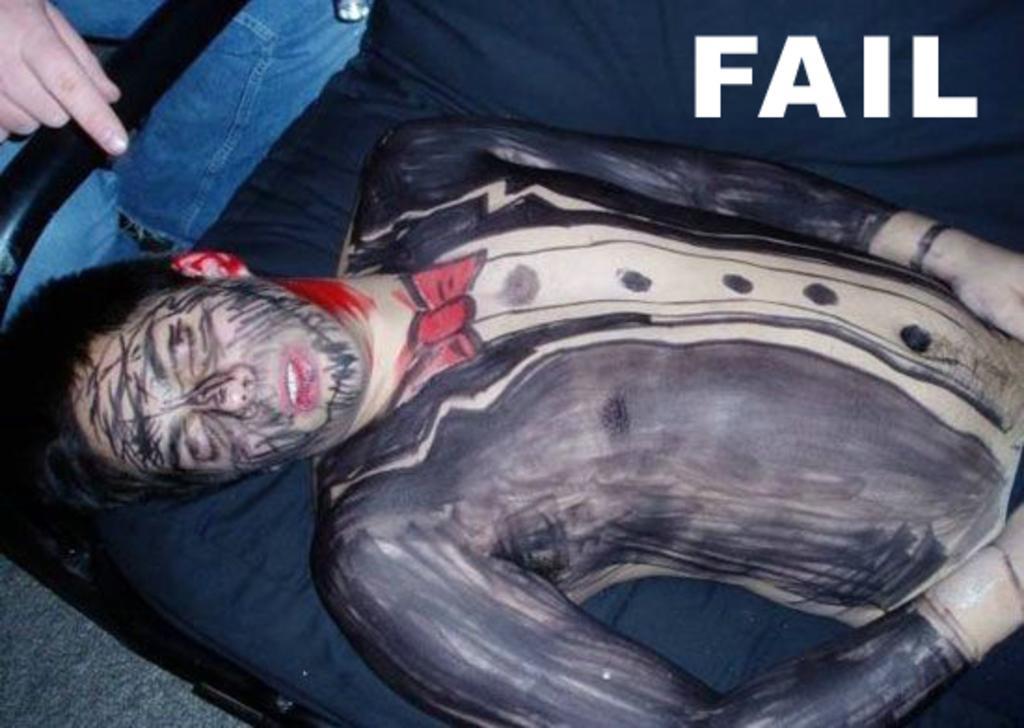Describe this image in one or two sentences. In this image I can see a person is lying on some object, metal rods, text and one person may be standing. This image is taken may be during a day. 